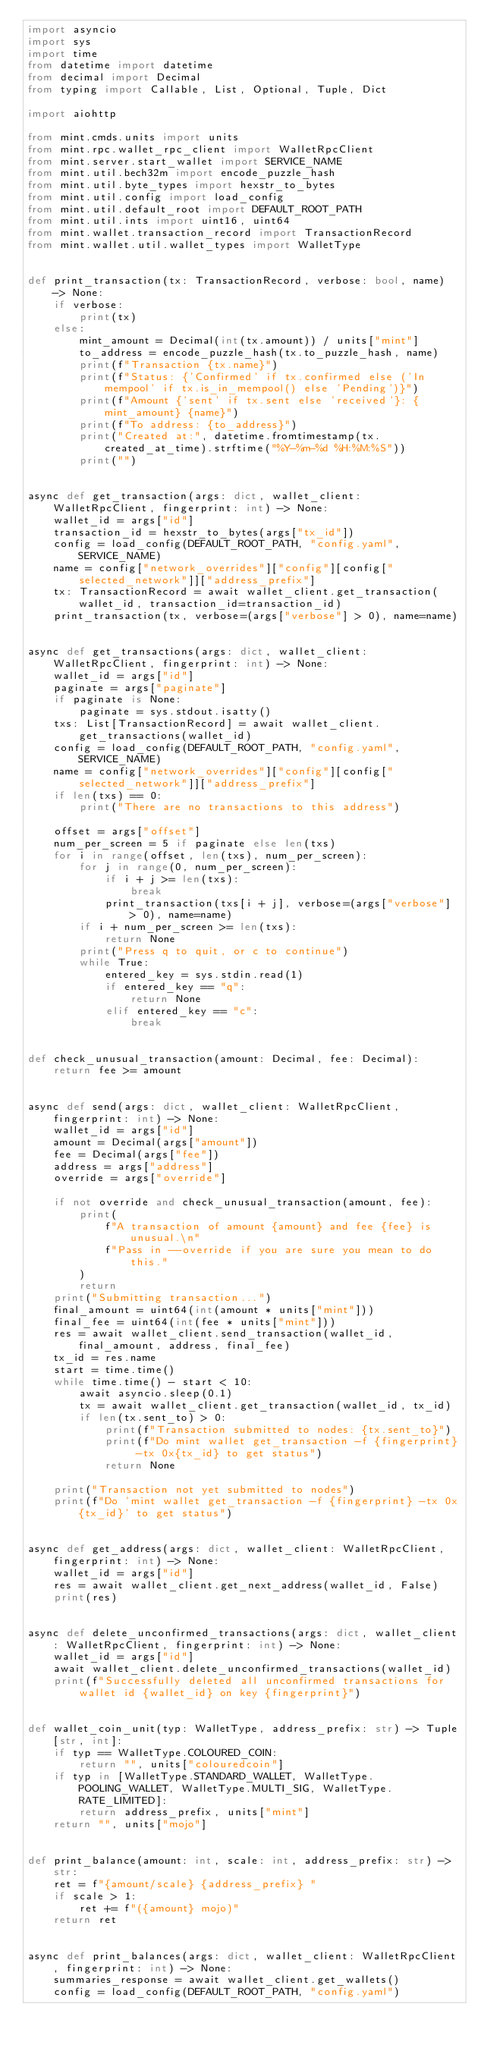Convert code to text. <code><loc_0><loc_0><loc_500><loc_500><_Python_>import asyncio
import sys
import time
from datetime import datetime
from decimal import Decimal
from typing import Callable, List, Optional, Tuple, Dict

import aiohttp

from mint.cmds.units import units
from mint.rpc.wallet_rpc_client import WalletRpcClient
from mint.server.start_wallet import SERVICE_NAME
from mint.util.bech32m import encode_puzzle_hash
from mint.util.byte_types import hexstr_to_bytes
from mint.util.config import load_config
from mint.util.default_root import DEFAULT_ROOT_PATH
from mint.util.ints import uint16, uint64
from mint.wallet.transaction_record import TransactionRecord
from mint.wallet.util.wallet_types import WalletType


def print_transaction(tx: TransactionRecord, verbose: bool, name) -> None:
    if verbose:
        print(tx)
    else:
        mint_amount = Decimal(int(tx.amount)) / units["mint"]
        to_address = encode_puzzle_hash(tx.to_puzzle_hash, name)
        print(f"Transaction {tx.name}")
        print(f"Status: {'Confirmed' if tx.confirmed else ('In mempool' if tx.is_in_mempool() else 'Pending')}")
        print(f"Amount {'sent' if tx.sent else 'received'}: {mint_amount} {name}")
        print(f"To address: {to_address}")
        print("Created at:", datetime.fromtimestamp(tx.created_at_time).strftime("%Y-%m-%d %H:%M:%S"))
        print("")


async def get_transaction(args: dict, wallet_client: WalletRpcClient, fingerprint: int) -> None:
    wallet_id = args["id"]
    transaction_id = hexstr_to_bytes(args["tx_id"])
    config = load_config(DEFAULT_ROOT_PATH, "config.yaml", SERVICE_NAME)
    name = config["network_overrides"]["config"][config["selected_network"]]["address_prefix"]
    tx: TransactionRecord = await wallet_client.get_transaction(wallet_id, transaction_id=transaction_id)
    print_transaction(tx, verbose=(args["verbose"] > 0), name=name)


async def get_transactions(args: dict, wallet_client: WalletRpcClient, fingerprint: int) -> None:
    wallet_id = args["id"]
    paginate = args["paginate"]
    if paginate is None:
        paginate = sys.stdout.isatty()
    txs: List[TransactionRecord] = await wallet_client.get_transactions(wallet_id)
    config = load_config(DEFAULT_ROOT_PATH, "config.yaml", SERVICE_NAME)
    name = config["network_overrides"]["config"][config["selected_network"]]["address_prefix"]
    if len(txs) == 0:
        print("There are no transactions to this address")

    offset = args["offset"]
    num_per_screen = 5 if paginate else len(txs)
    for i in range(offset, len(txs), num_per_screen):
        for j in range(0, num_per_screen):
            if i + j >= len(txs):
                break
            print_transaction(txs[i + j], verbose=(args["verbose"] > 0), name=name)
        if i + num_per_screen >= len(txs):
            return None
        print("Press q to quit, or c to continue")
        while True:
            entered_key = sys.stdin.read(1)
            if entered_key == "q":
                return None
            elif entered_key == "c":
                break


def check_unusual_transaction(amount: Decimal, fee: Decimal):
    return fee >= amount


async def send(args: dict, wallet_client: WalletRpcClient, fingerprint: int) -> None:
    wallet_id = args["id"]
    amount = Decimal(args["amount"])
    fee = Decimal(args["fee"])
    address = args["address"]
    override = args["override"]

    if not override and check_unusual_transaction(amount, fee):
        print(
            f"A transaction of amount {amount} and fee {fee} is unusual.\n"
            f"Pass in --override if you are sure you mean to do this."
        )
        return
    print("Submitting transaction...")
    final_amount = uint64(int(amount * units["mint"]))
    final_fee = uint64(int(fee * units["mint"]))
    res = await wallet_client.send_transaction(wallet_id, final_amount, address, final_fee)
    tx_id = res.name
    start = time.time()
    while time.time() - start < 10:
        await asyncio.sleep(0.1)
        tx = await wallet_client.get_transaction(wallet_id, tx_id)
        if len(tx.sent_to) > 0:
            print(f"Transaction submitted to nodes: {tx.sent_to}")
            print(f"Do mint wallet get_transaction -f {fingerprint} -tx 0x{tx_id} to get status")
            return None

    print("Transaction not yet submitted to nodes")
    print(f"Do 'mint wallet get_transaction -f {fingerprint} -tx 0x{tx_id}' to get status")


async def get_address(args: dict, wallet_client: WalletRpcClient, fingerprint: int) -> None:
    wallet_id = args["id"]
    res = await wallet_client.get_next_address(wallet_id, False)
    print(res)


async def delete_unconfirmed_transactions(args: dict, wallet_client: WalletRpcClient, fingerprint: int) -> None:
    wallet_id = args["id"]
    await wallet_client.delete_unconfirmed_transactions(wallet_id)
    print(f"Successfully deleted all unconfirmed transactions for wallet id {wallet_id} on key {fingerprint}")


def wallet_coin_unit(typ: WalletType, address_prefix: str) -> Tuple[str, int]:
    if typ == WalletType.COLOURED_COIN:
        return "", units["colouredcoin"]
    if typ in [WalletType.STANDARD_WALLET, WalletType.POOLING_WALLET, WalletType.MULTI_SIG, WalletType.RATE_LIMITED]:
        return address_prefix, units["mint"]
    return "", units["mojo"]


def print_balance(amount: int, scale: int, address_prefix: str) -> str:
    ret = f"{amount/scale} {address_prefix} "
    if scale > 1:
        ret += f"({amount} mojo)"
    return ret


async def print_balances(args: dict, wallet_client: WalletRpcClient, fingerprint: int) -> None:
    summaries_response = await wallet_client.get_wallets()
    config = load_config(DEFAULT_ROOT_PATH, "config.yaml")</code> 